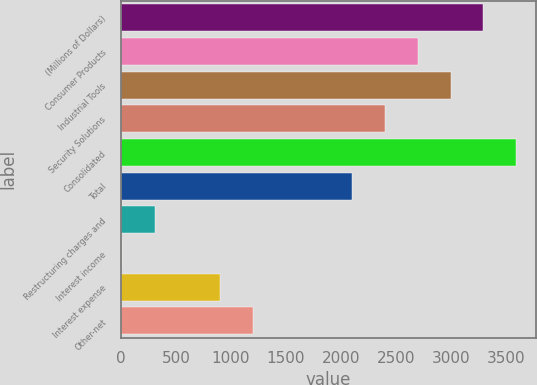<chart> <loc_0><loc_0><loc_500><loc_500><bar_chart><fcel>(Millions of Dollars)<fcel>Consumer Products<fcel>Industrial Tools<fcel>Security Solutions<fcel>Consolidated<fcel>Total<fcel>Restructuring charges and<fcel>Interest income<fcel>Interest expense<fcel>Other-net<nl><fcel>3296.72<fcel>2698.08<fcel>2997.4<fcel>2398.76<fcel>3596.04<fcel>2099.44<fcel>303.52<fcel>4.2<fcel>902.16<fcel>1201.48<nl></chart> 